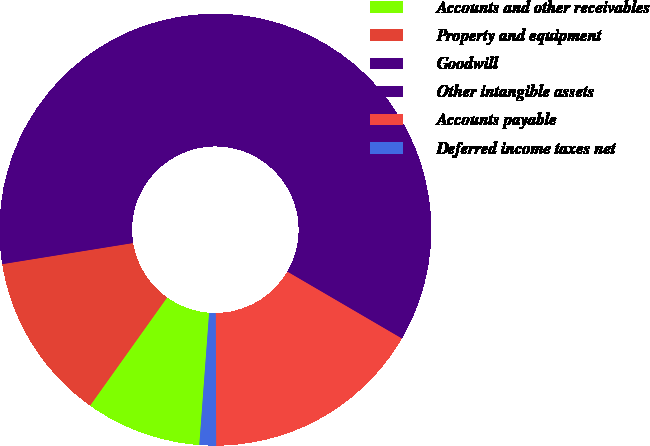Convert chart to OTSL. <chart><loc_0><loc_0><loc_500><loc_500><pie_chart><fcel>Accounts and other receivables<fcel>Property and equipment<fcel>Goodwill<fcel>Other intangible assets<fcel>Accounts payable<fcel>Deferred income taxes net<nl><fcel>8.67%<fcel>12.6%<fcel>40.51%<fcel>20.45%<fcel>16.53%<fcel>1.24%<nl></chart> 